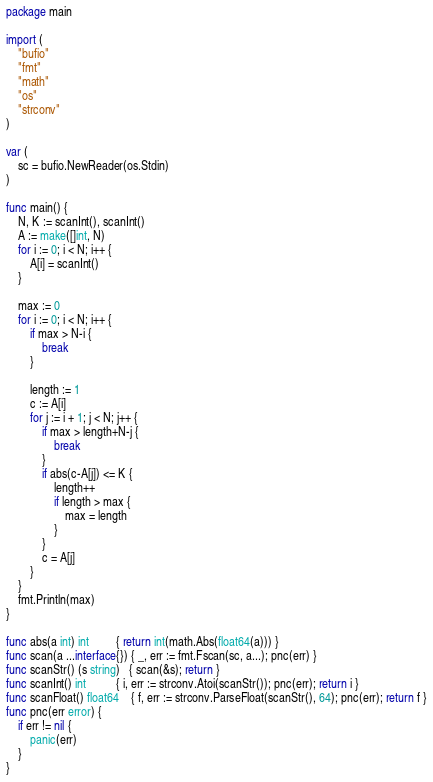Convert code to text. <code><loc_0><loc_0><loc_500><loc_500><_Go_>package main

import (
	"bufio"
	"fmt"
	"math"
	"os"
	"strconv"
)

var (
	sc = bufio.NewReader(os.Stdin)
)

func main() {
	N, K := scanInt(), scanInt()
	A := make([]int, N)
	for i := 0; i < N; i++ {
		A[i] = scanInt()
	}

	max := 0
	for i := 0; i < N; i++ {
		if max > N-i {
			break
		}

		length := 1
		c := A[i]
		for j := i + 1; j < N; j++ {
			if max > length+N-j {
				break
			}
			if abs(c-A[j]) <= K {
				length++
				if length > max {
					max = length
				}
			}
			c = A[j]
		}
	}
	fmt.Println(max)
}

func abs(a int) int         { return int(math.Abs(float64(a))) }
func scan(a ...interface{}) { _, err := fmt.Fscan(sc, a...); pnc(err) }
func scanStr() (s string)   { scan(&s); return }
func scanInt() int          { i, err := strconv.Atoi(scanStr()); pnc(err); return i }
func scanFloat() float64    { f, err := strconv.ParseFloat(scanStr(), 64); pnc(err); return f }
func pnc(err error) {
	if err != nil {
		panic(err)
	}
}
</code> 